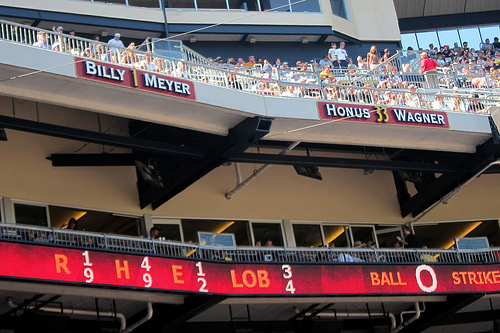<image>
Can you confirm if the people is above the score board? Yes. The people is positioned above the score board in the vertical space, higher up in the scene. 